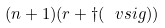<formula> <loc_0><loc_0><loc_500><loc_500>( n + 1 ) ( r + \dagger ( \ v s i g ) )</formula> 